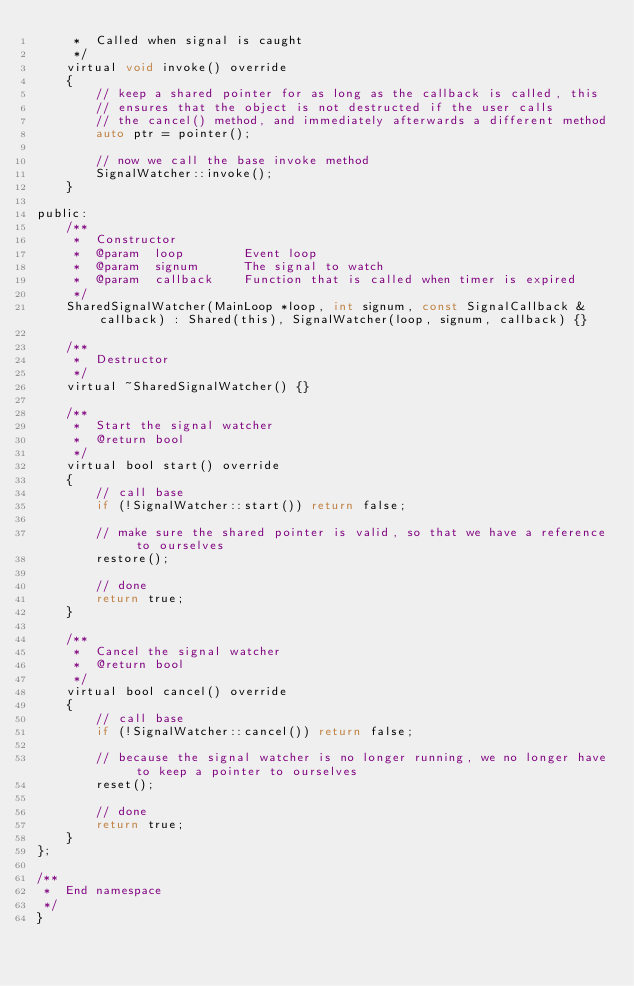Convert code to text. <code><loc_0><loc_0><loc_500><loc_500><_C_>     *  Called when signal is caught
     */
    virtual void invoke() override
    {
        // keep a shared pointer for as long as the callback is called, this
        // ensures that the object is not destructed if the user calls
        // the cancel() method, and immediately afterwards a different method
        auto ptr = pointer();

        // now we call the base invoke method
        SignalWatcher::invoke();
    }

public:
    /**
     *  Constructor
     *  @param  loop        Event loop
     *  @param  signum      The signal to watch
     *  @param  callback    Function that is called when timer is expired
     */
    SharedSignalWatcher(MainLoop *loop, int signum, const SignalCallback &callback) : Shared(this), SignalWatcher(loop, signum, callback) {}

    /**
     *  Destructor
     */
    virtual ~SharedSignalWatcher() {}

    /**
     *  Start the signal watcher
     *  @return bool
     */
    virtual bool start() override
    {
        // call base
        if (!SignalWatcher::start()) return false;

        // make sure the shared pointer is valid, so that we have a reference to ourselves
        restore();

        // done
        return true;
    }

    /**
     *  Cancel the signal watcher
     *  @return bool
     */
    virtual bool cancel() override
    {
        // call base
        if (!SignalWatcher::cancel()) return false;

        // because the signal watcher is no longer running, we no longer have to keep a pointer to ourselves
        reset();

        // done
        return true;
    }
};

/**
 *  End namespace
 */
}
</code> 